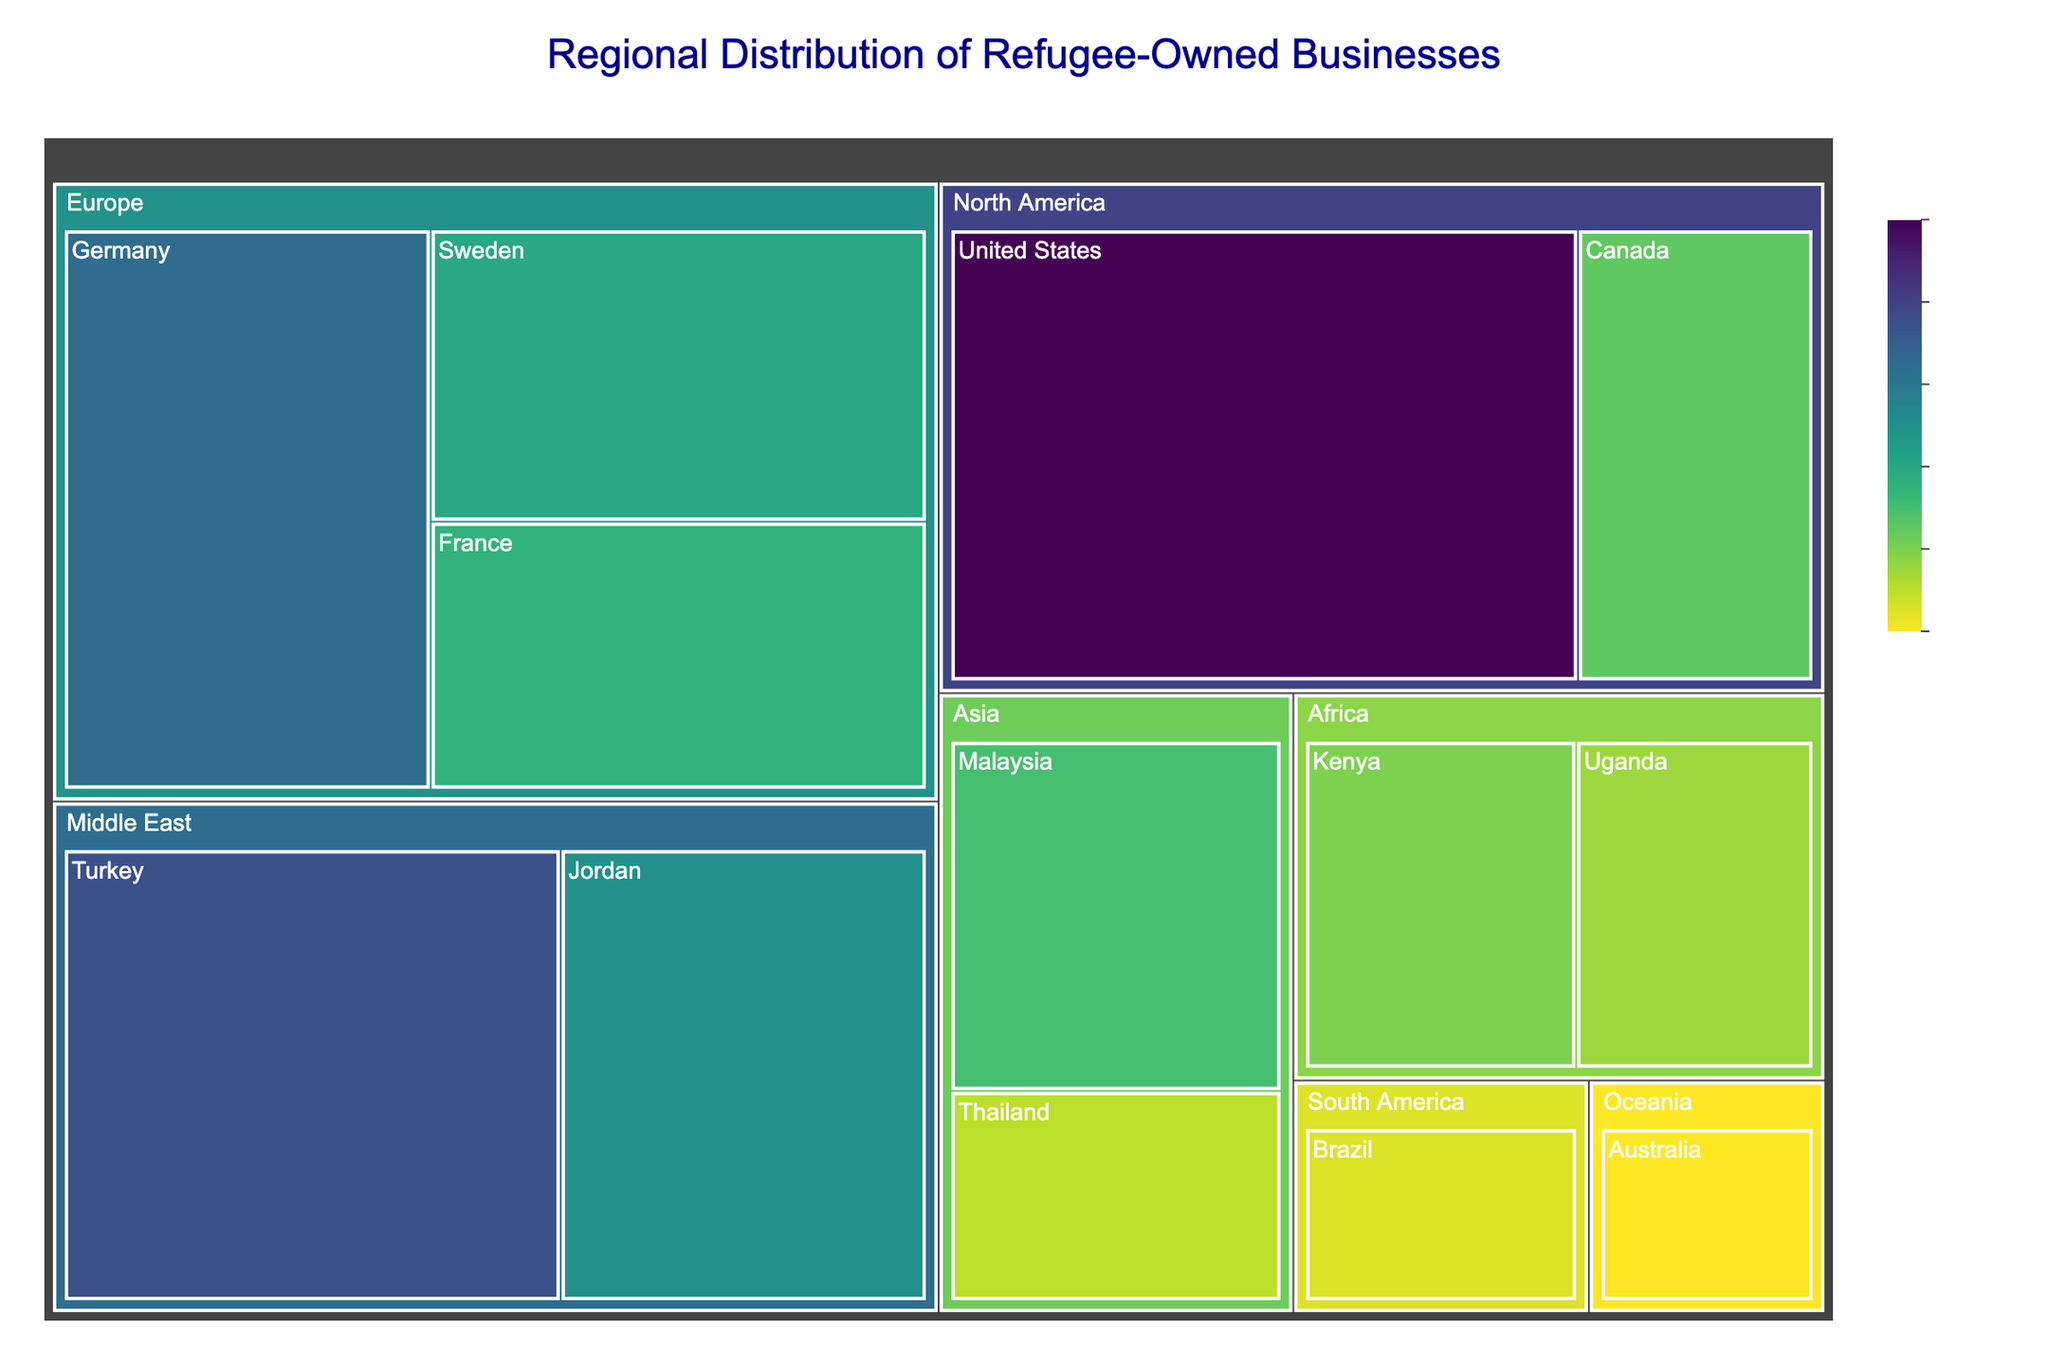How many businesses are supported in the Europe region? Sum up the number of businesses for all countries in Europe (Germany: 85, Sweden: 60, France: 55). The total is 85 + 60 + 55 = 200.
Answer: 200 Which country in North America has more refugee-owned businesses, the United States or Canada? Compare the number of businesses between the United States (120) and Canada (45). The United States has more businesses.
Answer: United States Which region has the smallest number of refugee-owned businesses supported by the organization? Identify the region with the smallest combined number of businesses. Oceania (Australia: 20) has the smallest number.
Answer: Oceania What is the total number of businesses supported across all regions? Sum up the number of businesses for all countries. 120 (US) + 45 (Canada) + 85 (Germany) + 60 (Sweden) + 55 (France) + 95 (Turkey) + 70 (Jordan) + 40 (Kenya) + 35 (Uganda) + 50 (Malaysia) + 30 (Thailand) + 25 (Brazil) + 20 (Australia) = 730.
Answer: 730 Which countries are listed under the Middle East region and how many businesses do they have in total? The Middle East region includes Turkey (95) and Jordan (70). Total businesses = 95 + 70 = 165.
Answer: Turkey and Jordan, 165 Is the number of businesses in France greater than or less than in Malaysia? Compare the number of businesses in France (55) and Malaysia (50). France has more businesses than Malaysia.
Answer: Greater What is the average number of businesses per country in Africa? Sum the number of businesses in Kenya (40) and Uganda (35) and then divide by the number of countries (2). (40 + 35) / 2 = 37.5.
Answer: 37.5 Which country in Asia has the most refugee-owned businesses supported by the organization? Compare the number of businesses between Malaysia (50) and Thailand (30). Malaysia has the most businesses.
Answer: Malaysia What proportion of all businesses are located in the North America region? Sum the number of businesses in North America (120 US + 45 Canada = 165) and divide by the total number (730). 165 / 730 ≈ 0.226 or 22.6%.
Answer: 22.6% By how much does the number of businesses in Turkey exceed those in Sweden? Subtract the number of businesses in Sweden (60) from Turkey (95). 95 - 60 = 35.
Answer: 35 